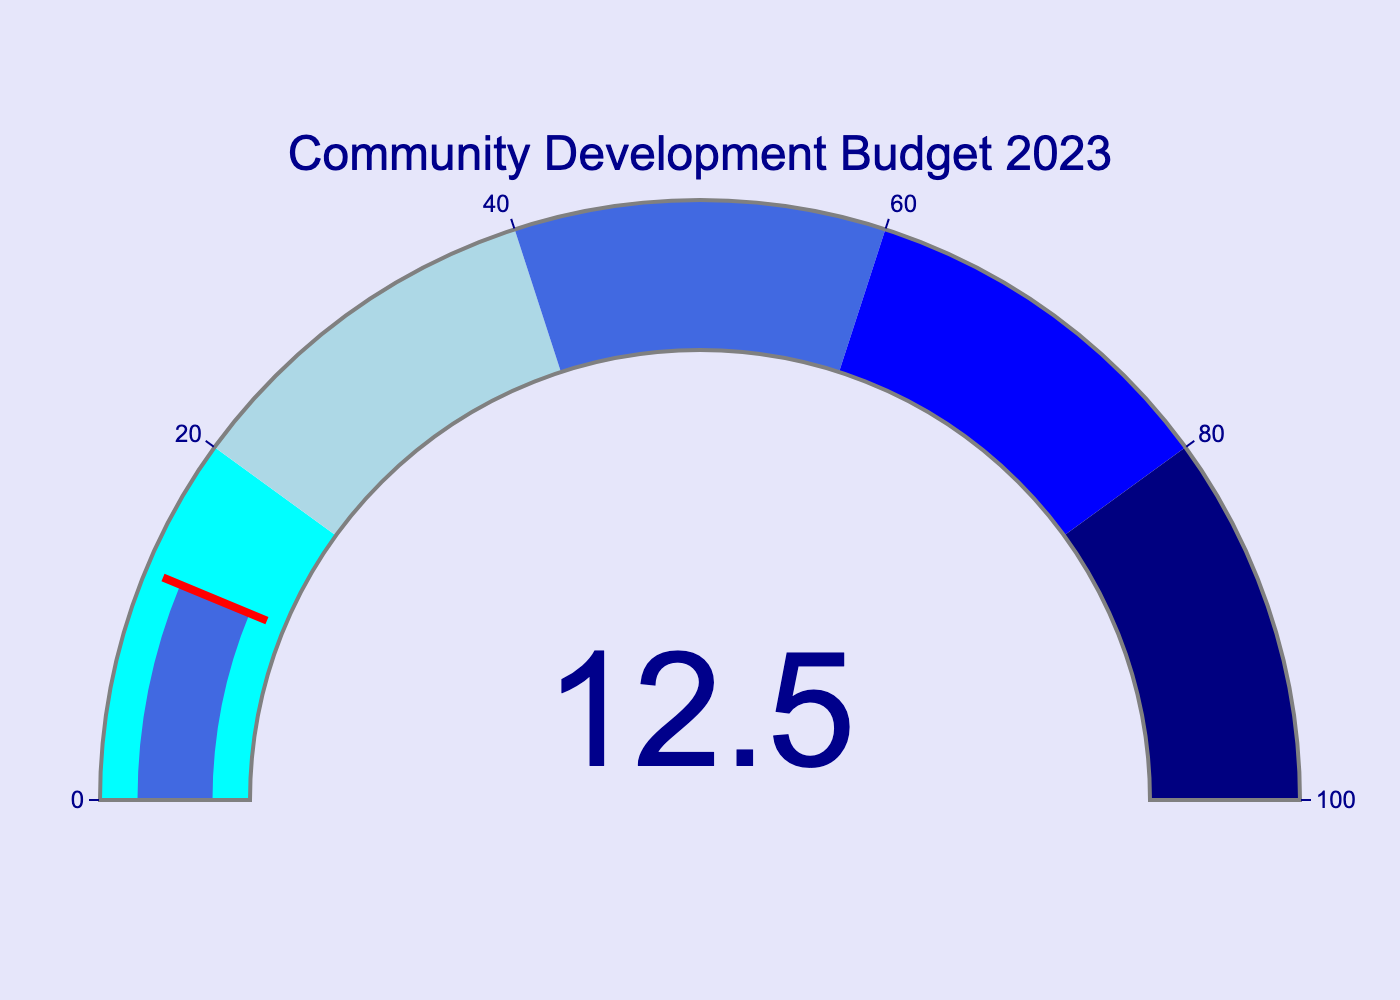what is the percentage of the city budget allocated to community development projects in 2023? The figure shows a gauge indicating the percentage allocated for the year. In 2023, it points to 12.5%.
Answer: 12.5% What is the title of the gauge chart? The title is prominently displayed at the top of the figure in dark blue. It reads "Community Development Budget 2023".
Answer: Community Development Budget 2023 What is the range of the gauge? The gauge has a range that is indicated along the axis. It goes from 0 to 100.
Answer: 0 to 100 What color is the section of the gauge between 20 and 40%? Each section of the gauge is color-coded. The section between 20 and 40% is light blue.
Answer: light blue If the percentage was doubled, what would it be? The given percentage is 12.5%. Doubling it means multiplying by 2. Thus, 12.5% * 2 equals 25%.
Answer: 25% Is the percentage allocated to community development projects above or below 20%? The gauge indicates that the percentage is 12.5%, which is below 20%.
Answer: Below How much more percentage is needed to reach the next section of the gauge? The current percentage is 12.5%. The next section starts at 20%. The additional percentage needed is 20% - 12.5% = 7.5%.
Answer: 7.5% What color is the gauge bar indicating the percentage? The bar showing the current percentage is colored royal blue.
Answer: royal blue Is the threshold indicator above or below the current percentage? The threshold indicator line is shown at the current percentage value; therefore, it is at the same level, not above or below.
Answer: Same level 